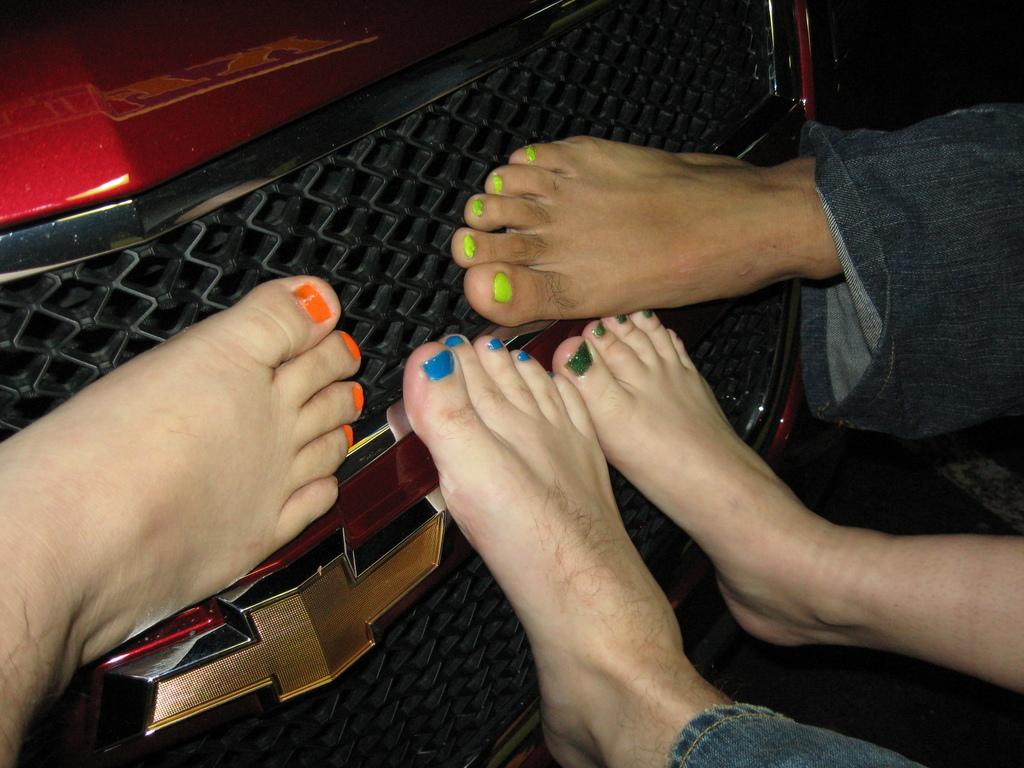How many legs can be seen in the image? There are 4 legs visible in the image. What is applied to the nails in the image? Nail polish is present on the nails. What part of a car is visible in the image? The front part of a car is visible in the image. Can you describe the logo on the car? There is a logo on the car, but the specific design or brand cannot be determined from the image. How many beggars are present in the image? There are no beggars present in the image. What type of angle is depicted in the image? The image does not depict an angle; it shows a car and legs with nail polish. 